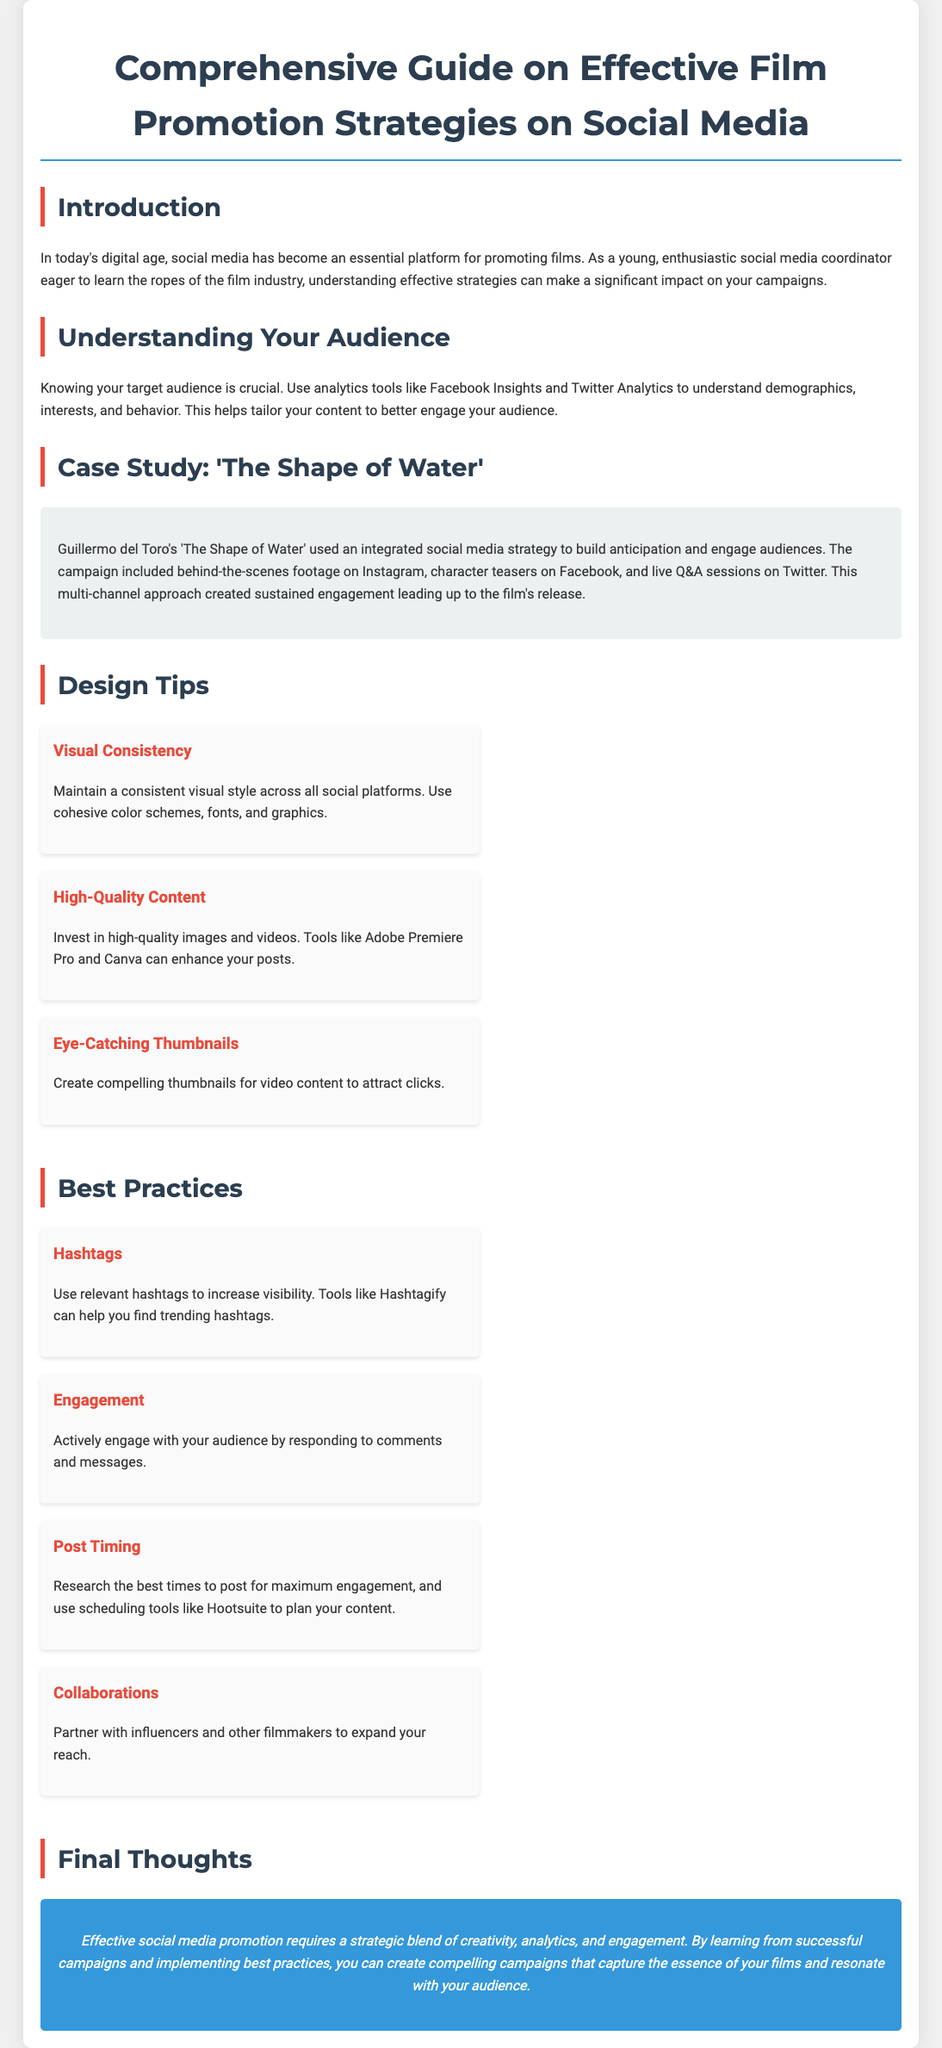what is the title of the document? The title of the document is found in the main header at the top of the content.
Answer: Comprehensive Guide on Effective Film Promotion Strategies on Social Media who directed 'The Shape of Water'? The name of the director is mentioned in the case study section regarding the film.
Answer: Guillermo del Toro what tool is recommended for finding trending hashtags? The document specifies a tool in the best practices section for hashtag research.
Answer: Hashtagify how many design tips are listed in the document? This question pertains to the number of tips provided in the design tips section.
Answer: 3 what is the recommended action to increase audience engagement? The best practices section suggests a specific way to interact with the audience actively.
Answer: Responding to comments and messages what is the color scheme used for the final thoughts section? The document describes the background color and text color specifically in the final thoughts section.
Answer: Blue background with white text which social media platform is mentioned for posting timing research? This refers to the platform suggested for planning and timing post schedules in the document.
Answer: Hootsuite what is emphasized as the main requirement for effective social media promotion? The final thoughts section summarizes what is essential for successful promotion strategies.
Answer: Strategic blend of creativity, analytics, and engagement 